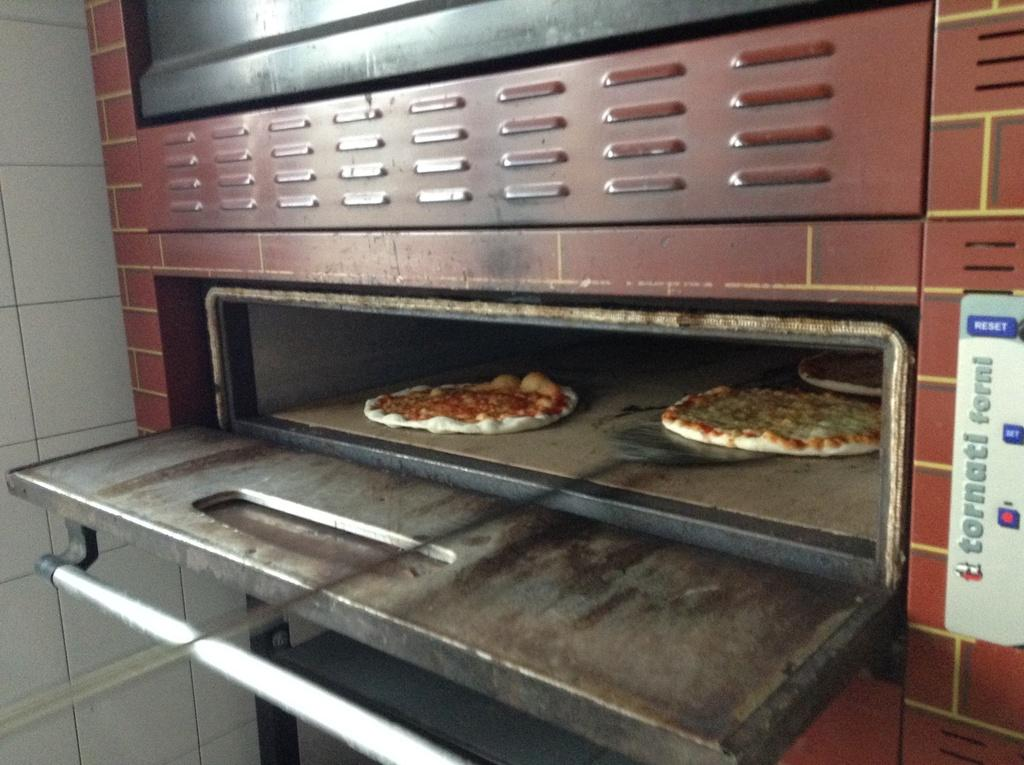Provide a one-sentence caption for the provided image. A Tornati Forni oven is baking two pizzas inside. 